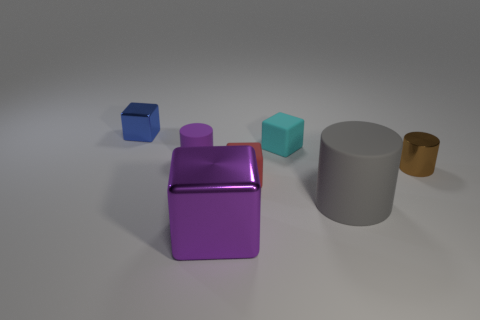Subtract all red cubes. How many cubes are left? 3 Add 2 large purple blocks. How many objects exist? 9 Subtract all blue cubes. How many cubes are left? 3 Subtract 2 cubes. How many cubes are left? 2 Subtract all cylinders. How many objects are left? 4 Subtract all small cyan rubber blocks. Subtract all blue things. How many objects are left? 5 Add 1 big gray things. How many big gray things are left? 2 Add 5 large shiny things. How many large shiny things exist? 6 Subtract 0 purple spheres. How many objects are left? 7 Subtract all yellow cylinders. Subtract all blue spheres. How many cylinders are left? 3 